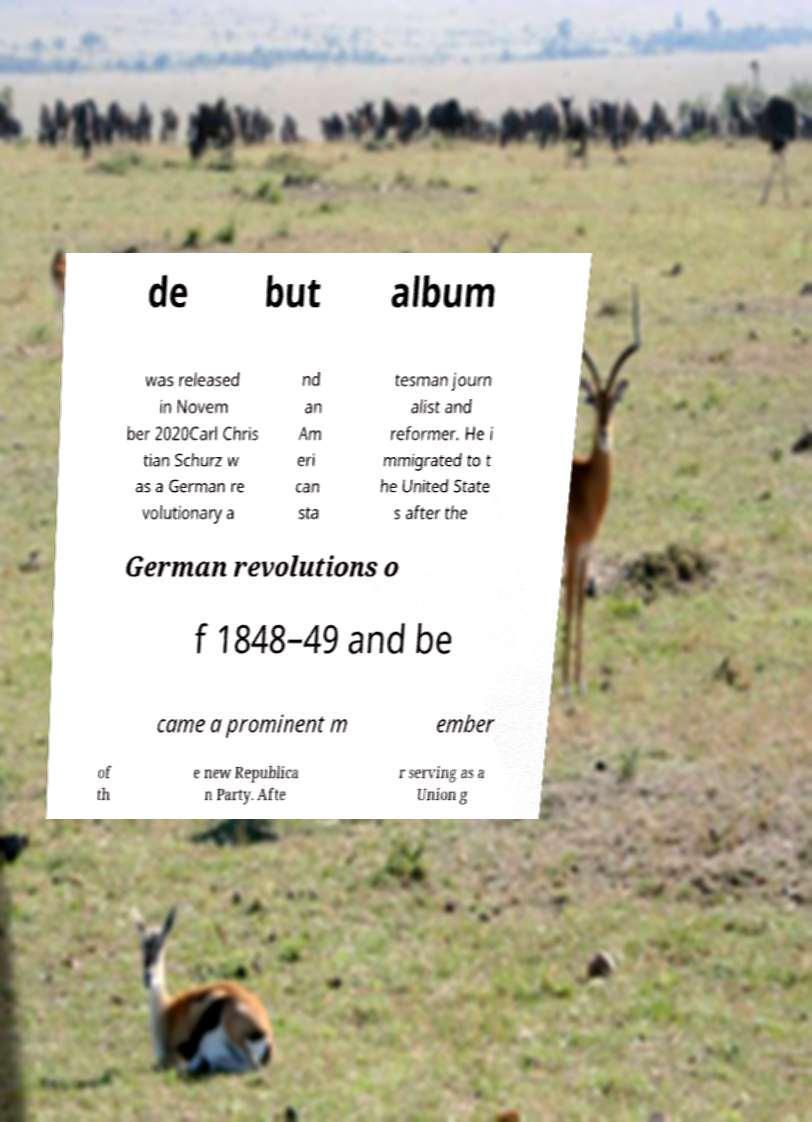I need the written content from this picture converted into text. Can you do that? de but album was released in Novem ber 2020Carl Chris tian Schurz w as a German re volutionary a nd an Am eri can sta tesman journ alist and reformer. He i mmigrated to t he United State s after the German revolutions o f 1848–49 and be came a prominent m ember of th e new Republica n Party. Afte r serving as a Union g 